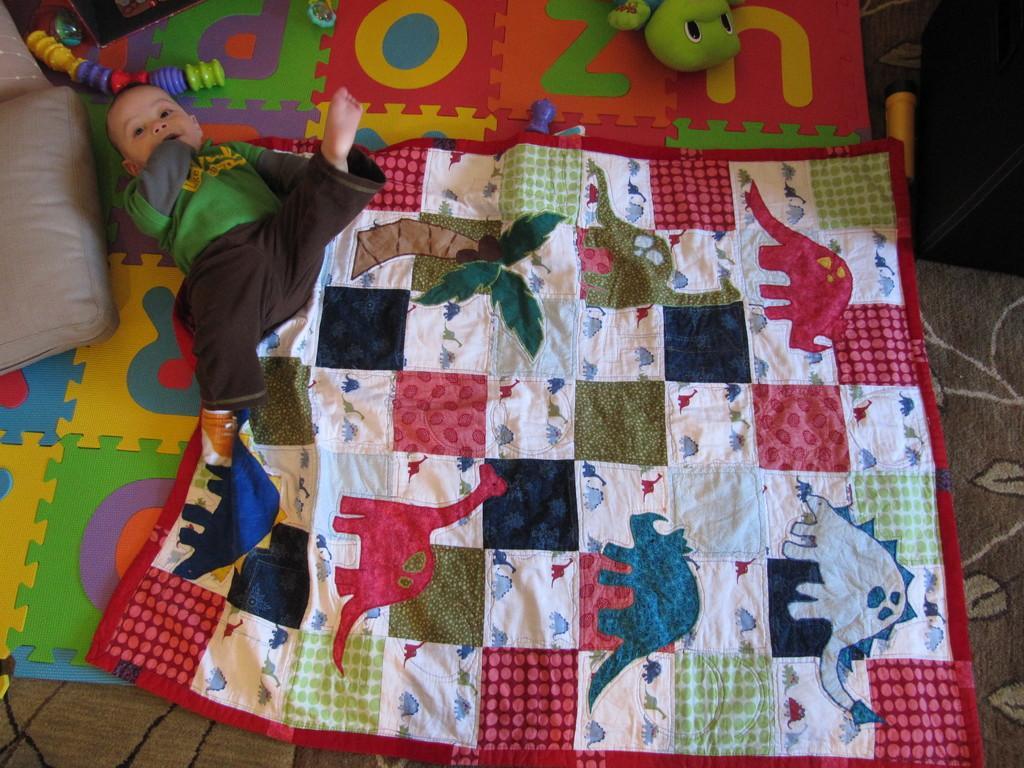In one or two sentences, can you explain what this image depicts? In this picture we can see a baby is lying on the cloth. On the left side of the image, it looks like a pillow. At the top of the image, there are toys. 